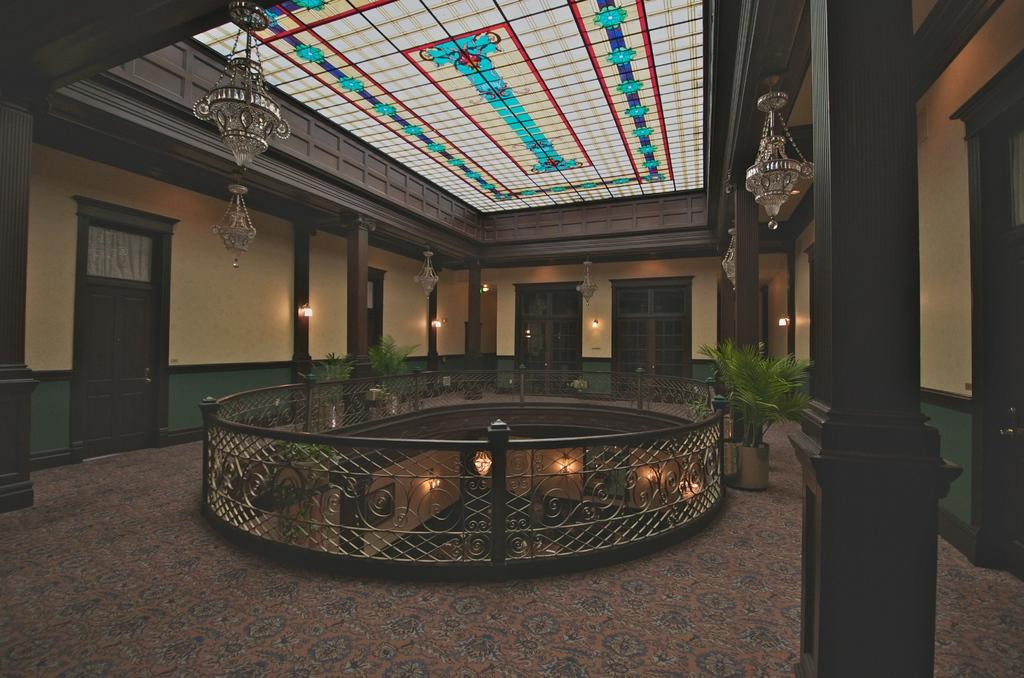What type of structure is depicted in the image? The image is of a building. What architectural features can be seen on the building? There are pillars, doors, windows, and a grille visible in the image. Are there any decorative elements present in the image? Yes, there are potted plants in the image. What can be seen on the walls of the building? The wall is visible in the image. What type of yam is being used as a decoration on the building's facade? There is no yam present in the image; it is a building with architectural features and decorative elements such as pillars, doors, windows, and potted plants. 